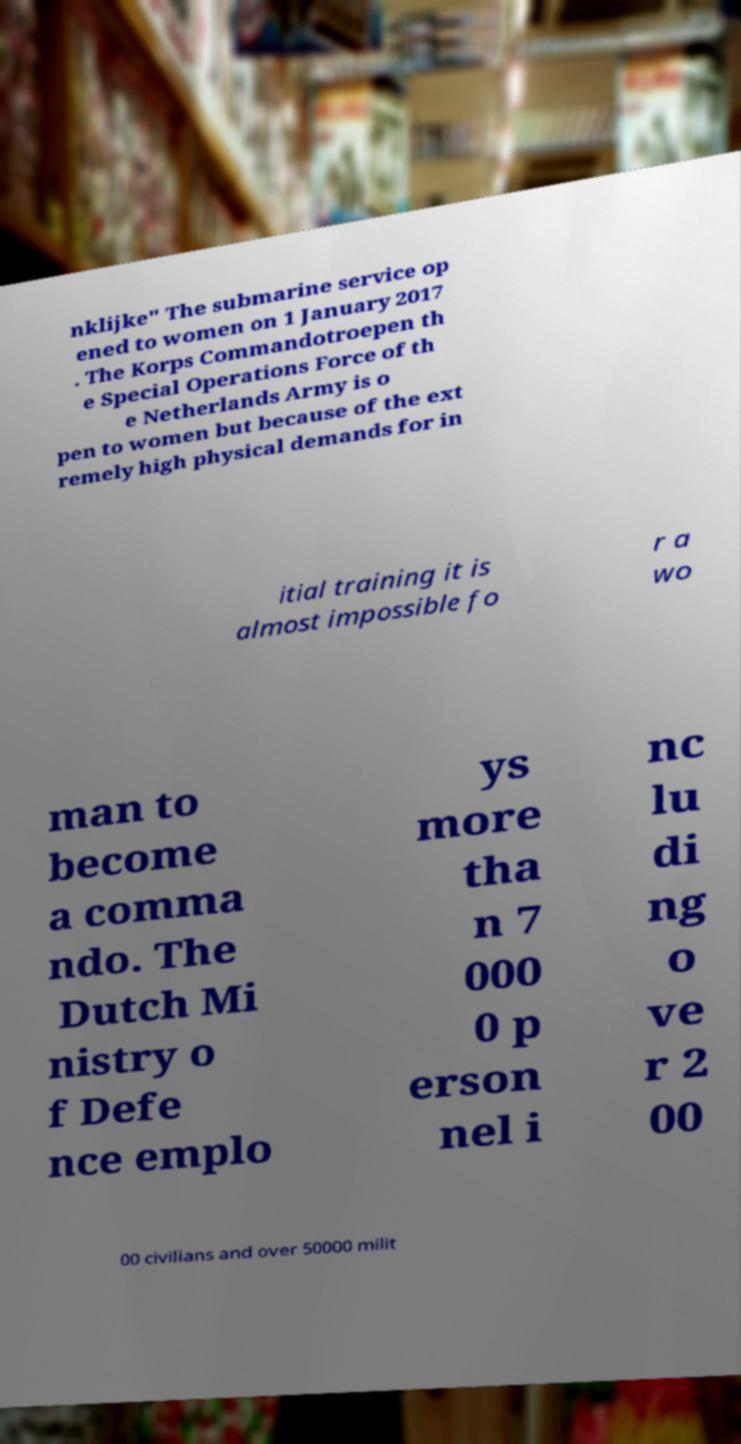For documentation purposes, I need the text within this image transcribed. Could you provide that? nklijke" The submarine service op ened to women on 1 January 2017 . The Korps Commandotroepen th e Special Operations Force of th e Netherlands Army is o pen to women but because of the ext remely high physical demands for in itial training it is almost impossible fo r a wo man to become a comma ndo. The Dutch Mi nistry o f Defe nce emplo ys more tha n 7 000 0 p erson nel i nc lu di ng o ve r 2 00 00 civilians and over 50000 milit 